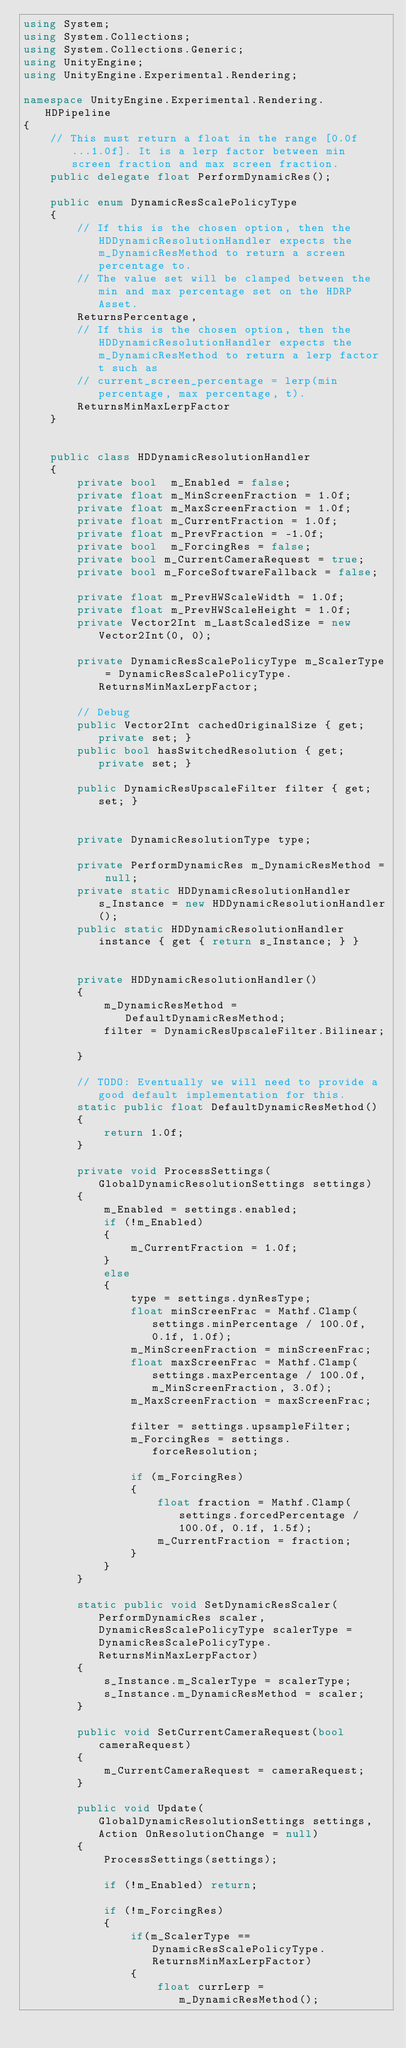<code> <loc_0><loc_0><loc_500><loc_500><_C#_>using System;
using System.Collections;
using System.Collections.Generic;
using UnityEngine;
using UnityEngine.Experimental.Rendering;

namespace UnityEngine.Experimental.Rendering.HDPipeline
{
    // This must return a float in the range [0.0f...1.0f]. It is a lerp factor between min screen fraction and max screen fraction.  
    public delegate float PerformDynamicRes();      

    public enum DynamicResScalePolicyType
    {
        // If this is the chosen option, then the HDDynamicResolutionHandler expects the m_DynamicResMethod to return a screen percentage to.
        // The value set will be clamped between the min and max percentage set on the HDRP Asset. 
        ReturnsPercentage,
        // If this is the chosen option, then the HDDynamicResolutionHandler expects the m_DynamicResMethod to return a lerp factor t such as
        // current_screen_percentage = lerp(min percentage, max percentage, t). 
        ReturnsMinMaxLerpFactor
    }


    public class HDDynamicResolutionHandler
    {
        private bool  m_Enabled = false;
        private float m_MinScreenFraction = 1.0f;
        private float m_MaxScreenFraction = 1.0f;
        private float m_CurrentFraction = 1.0f;
        private float m_PrevFraction = -1.0f;
        private bool  m_ForcingRes = false;
        private bool m_CurrentCameraRequest = true;
        private bool m_ForceSoftwareFallback = false;

        private float m_PrevHWScaleWidth = 1.0f;
        private float m_PrevHWScaleHeight = 1.0f;
        private Vector2Int m_LastScaledSize = new Vector2Int(0, 0);

        private DynamicResScalePolicyType m_ScalerType = DynamicResScalePolicyType.ReturnsMinMaxLerpFactor;

        // Debug
        public Vector2Int cachedOriginalSize { get; private set; }
        public bool hasSwitchedResolution { get; private set; }

        public DynamicResUpscaleFilter filter { get; set; }


        private DynamicResolutionType type;

        private PerformDynamicRes m_DynamicResMethod = null;
        private static HDDynamicResolutionHandler s_Instance = new HDDynamicResolutionHandler();
        public static HDDynamicResolutionHandler instance { get { return s_Instance; } }


        private HDDynamicResolutionHandler()
        {
            m_DynamicResMethod = DefaultDynamicResMethod;
            filter = DynamicResUpscaleFilter.Bilinear;

        }

        // TODO: Eventually we will need to provide a good default implementation for this. 
        static public float DefaultDynamicResMethod()
        {
            return 1.0f;
        }

        private void ProcessSettings(GlobalDynamicResolutionSettings settings)
        {
            m_Enabled = settings.enabled;
            if (!m_Enabled)
            {
                m_CurrentFraction = 1.0f;
            }
            else
            {
                type = settings.dynResType;
                float minScreenFrac = Mathf.Clamp(settings.minPercentage / 100.0f, 0.1f, 1.0f);
                m_MinScreenFraction = minScreenFrac;
                float maxScreenFrac = Mathf.Clamp(settings.maxPercentage / 100.0f, m_MinScreenFraction, 3.0f);
                m_MaxScreenFraction = maxScreenFrac;

                filter = settings.upsampleFilter;
                m_ForcingRes = settings.forceResolution;

                if (m_ForcingRes)
                {
                    float fraction = Mathf.Clamp(settings.forcedPercentage / 100.0f, 0.1f, 1.5f);
                    m_CurrentFraction = fraction;
                }
            }
        }

        static public void SetDynamicResScaler(PerformDynamicRes scaler, DynamicResScalePolicyType scalerType = DynamicResScalePolicyType.ReturnsMinMaxLerpFactor)
        {
            s_Instance.m_ScalerType = scalerType;
            s_Instance.m_DynamicResMethod = scaler;
        }

        public void SetCurrentCameraRequest(bool cameraRequest)
        {
            m_CurrentCameraRequest = cameraRequest;
        }

        public void Update(GlobalDynamicResolutionSettings settings, Action OnResolutionChange = null)
        {
            ProcessSettings(settings);

            if (!m_Enabled) return;

            if (!m_ForcingRes)
            {
                if(m_ScalerType == DynamicResScalePolicyType.ReturnsMinMaxLerpFactor)
                {
                    float currLerp = m_DynamicResMethod();</code> 